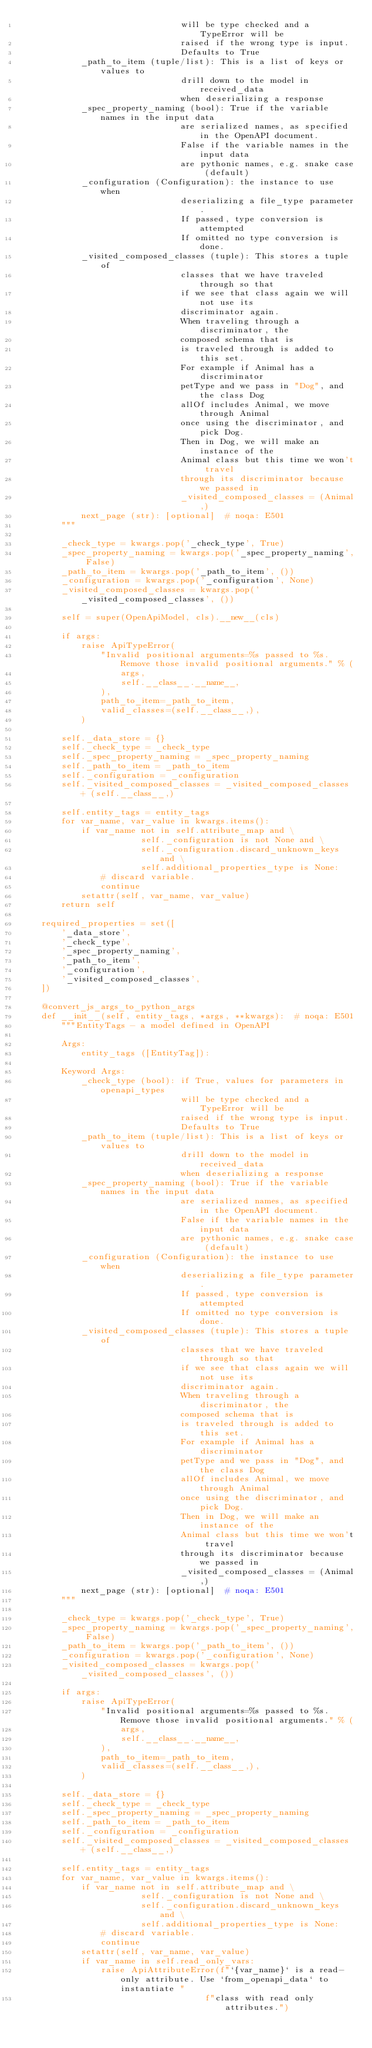Convert code to text. <code><loc_0><loc_0><loc_500><loc_500><_Python_>                                will be type checked and a TypeError will be
                                raised if the wrong type is input.
                                Defaults to True
            _path_to_item (tuple/list): This is a list of keys or values to
                                drill down to the model in received_data
                                when deserializing a response
            _spec_property_naming (bool): True if the variable names in the input data
                                are serialized names, as specified in the OpenAPI document.
                                False if the variable names in the input data
                                are pythonic names, e.g. snake case (default)
            _configuration (Configuration): the instance to use when
                                deserializing a file_type parameter.
                                If passed, type conversion is attempted
                                If omitted no type conversion is done.
            _visited_composed_classes (tuple): This stores a tuple of
                                classes that we have traveled through so that
                                if we see that class again we will not use its
                                discriminator again.
                                When traveling through a discriminator, the
                                composed schema that is
                                is traveled through is added to this set.
                                For example if Animal has a discriminator
                                petType and we pass in "Dog", and the class Dog
                                allOf includes Animal, we move through Animal
                                once using the discriminator, and pick Dog.
                                Then in Dog, we will make an instance of the
                                Animal class but this time we won't travel
                                through its discriminator because we passed in
                                _visited_composed_classes = (Animal,)
            next_page (str): [optional]  # noqa: E501
        """

        _check_type = kwargs.pop('_check_type', True)
        _spec_property_naming = kwargs.pop('_spec_property_naming', False)
        _path_to_item = kwargs.pop('_path_to_item', ())
        _configuration = kwargs.pop('_configuration', None)
        _visited_composed_classes = kwargs.pop('_visited_composed_classes', ())

        self = super(OpenApiModel, cls).__new__(cls)

        if args:
            raise ApiTypeError(
                "Invalid positional arguments=%s passed to %s. Remove those invalid positional arguments." % (
                    args,
                    self.__class__.__name__,
                ),
                path_to_item=_path_to_item,
                valid_classes=(self.__class__,),
            )

        self._data_store = {}
        self._check_type = _check_type
        self._spec_property_naming = _spec_property_naming
        self._path_to_item = _path_to_item
        self._configuration = _configuration
        self._visited_composed_classes = _visited_composed_classes + (self.__class__,)

        self.entity_tags = entity_tags
        for var_name, var_value in kwargs.items():
            if var_name not in self.attribute_map and \
                        self._configuration is not None and \
                        self._configuration.discard_unknown_keys and \
                        self.additional_properties_type is None:
                # discard variable.
                continue
            setattr(self, var_name, var_value)
        return self

    required_properties = set([
        '_data_store',
        '_check_type',
        '_spec_property_naming',
        '_path_to_item',
        '_configuration',
        '_visited_composed_classes',
    ])

    @convert_js_args_to_python_args
    def __init__(self, entity_tags, *args, **kwargs):  # noqa: E501
        """EntityTags - a model defined in OpenAPI

        Args:
            entity_tags ([EntityTag]):

        Keyword Args:
            _check_type (bool): if True, values for parameters in openapi_types
                                will be type checked and a TypeError will be
                                raised if the wrong type is input.
                                Defaults to True
            _path_to_item (tuple/list): This is a list of keys or values to
                                drill down to the model in received_data
                                when deserializing a response
            _spec_property_naming (bool): True if the variable names in the input data
                                are serialized names, as specified in the OpenAPI document.
                                False if the variable names in the input data
                                are pythonic names, e.g. snake case (default)
            _configuration (Configuration): the instance to use when
                                deserializing a file_type parameter.
                                If passed, type conversion is attempted
                                If omitted no type conversion is done.
            _visited_composed_classes (tuple): This stores a tuple of
                                classes that we have traveled through so that
                                if we see that class again we will not use its
                                discriminator again.
                                When traveling through a discriminator, the
                                composed schema that is
                                is traveled through is added to this set.
                                For example if Animal has a discriminator
                                petType and we pass in "Dog", and the class Dog
                                allOf includes Animal, we move through Animal
                                once using the discriminator, and pick Dog.
                                Then in Dog, we will make an instance of the
                                Animal class but this time we won't travel
                                through its discriminator because we passed in
                                _visited_composed_classes = (Animal,)
            next_page (str): [optional]  # noqa: E501
        """

        _check_type = kwargs.pop('_check_type', True)
        _spec_property_naming = kwargs.pop('_spec_property_naming', False)
        _path_to_item = kwargs.pop('_path_to_item', ())
        _configuration = kwargs.pop('_configuration', None)
        _visited_composed_classes = kwargs.pop('_visited_composed_classes', ())

        if args:
            raise ApiTypeError(
                "Invalid positional arguments=%s passed to %s. Remove those invalid positional arguments." % (
                    args,
                    self.__class__.__name__,
                ),
                path_to_item=_path_to_item,
                valid_classes=(self.__class__,),
            )

        self._data_store = {}
        self._check_type = _check_type
        self._spec_property_naming = _spec_property_naming
        self._path_to_item = _path_to_item
        self._configuration = _configuration
        self._visited_composed_classes = _visited_composed_classes + (self.__class__,)

        self.entity_tags = entity_tags
        for var_name, var_value in kwargs.items():
            if var_name not in self.attribute_map and \
                        self._configuration is not None and \
                        self._configuration.discard_unknown_keys and \
                        self.additional_properties_type is None:
                # discard variable.
                continue
            setattr(self, var_name, var_value)
            if var_name in self.read_only_vars:
                raise ApiAttributeError(f"`{var_name}` is a read-only attribute. Use `from_openapi_data` to instantiate "
                                     f"class with read only attributes.")
</code> 